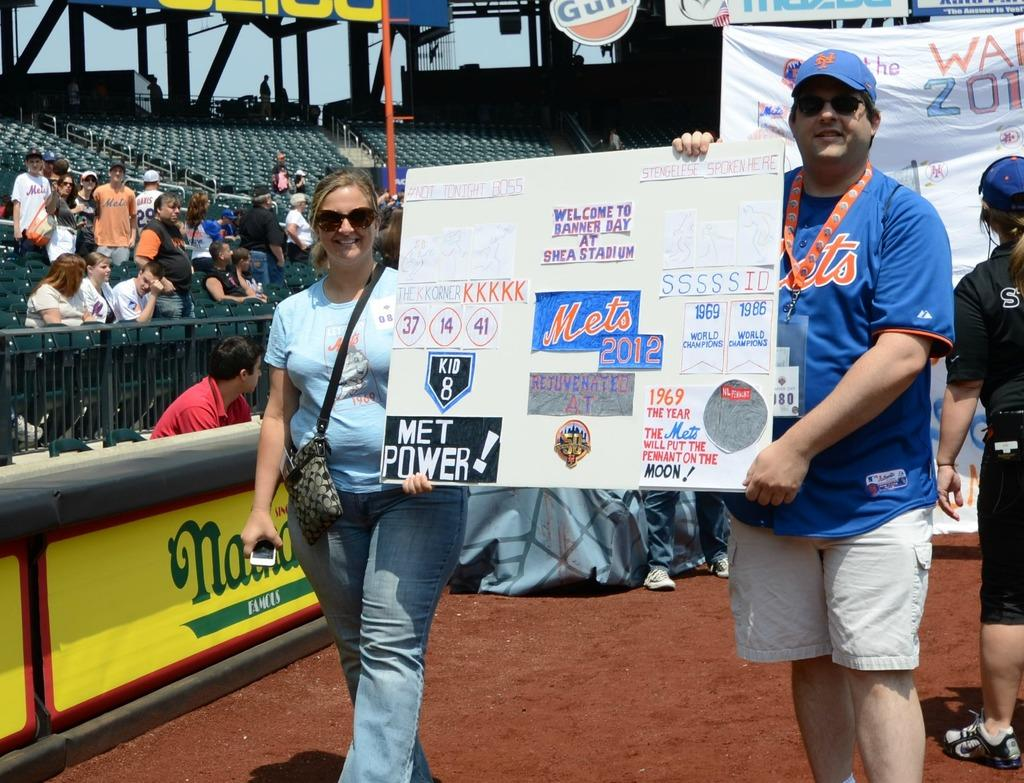Provide a one-sentence caption for the provided image. A man and woman holding a sign that says "Welcome to Banner Day at Shea Stadium". 